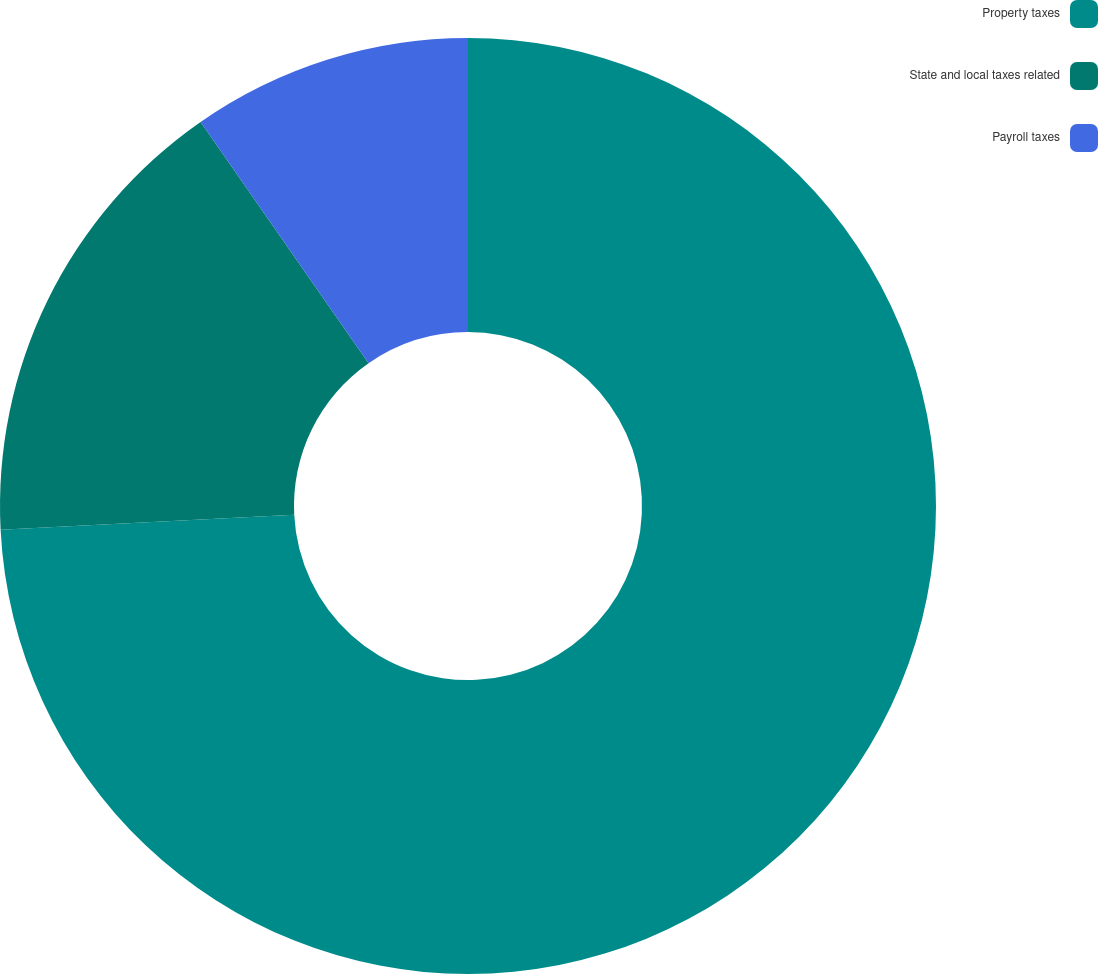Convert chart. <chart><loc_0><loc_0><loc_500><loc_500><pie_chart><fcel>Property taxes<fcel>State and local taxes related<fcel>Payroll taxes<nl><fcel>74.19%<fcel>16.13%<fcel>9.68%<nl></chart> 